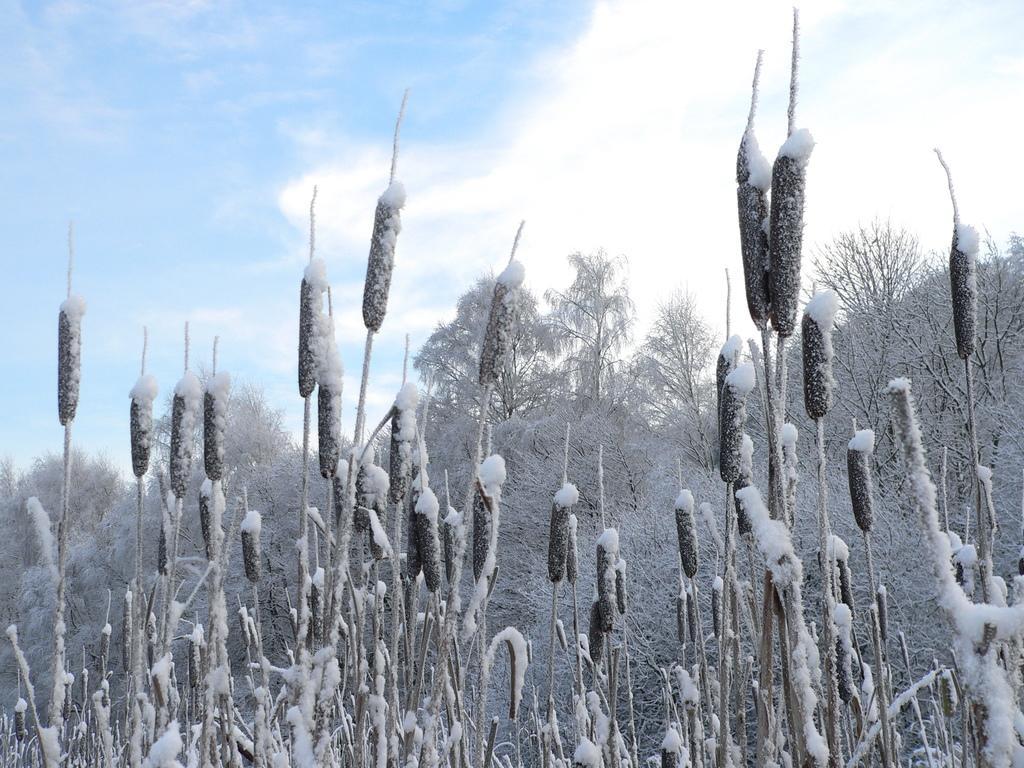In one or two sentences, can you explain what this image depicts? In this picture there are few trees covered with snow. 